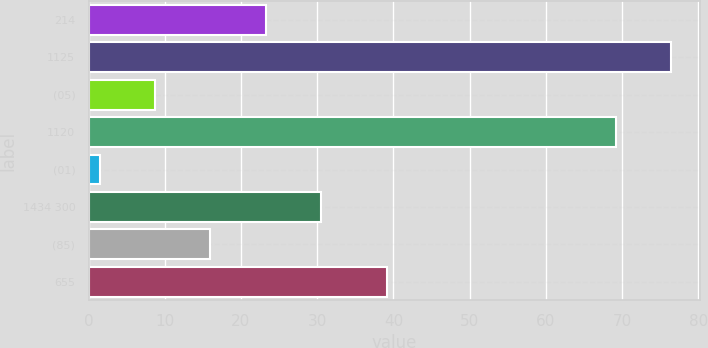Convert chart. <chart><loc_0><loc_0><loc_500><loc_500><bar_chart><fcel>214<fcel>1125<fcel>(05)<fcel>1120<fcel>(01)<fcel>1434 300<fcel>(85)<fcel>655<nl><fcel>23.22<fcel>76.44<fcel>8.74<fcel>69.2<fcel>1.5<fcel>30.46<fcel>15.98<fcel>39.2<nl></chart> 